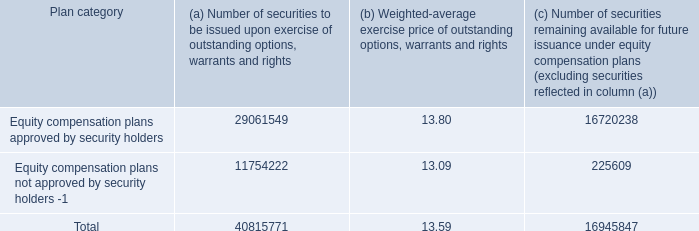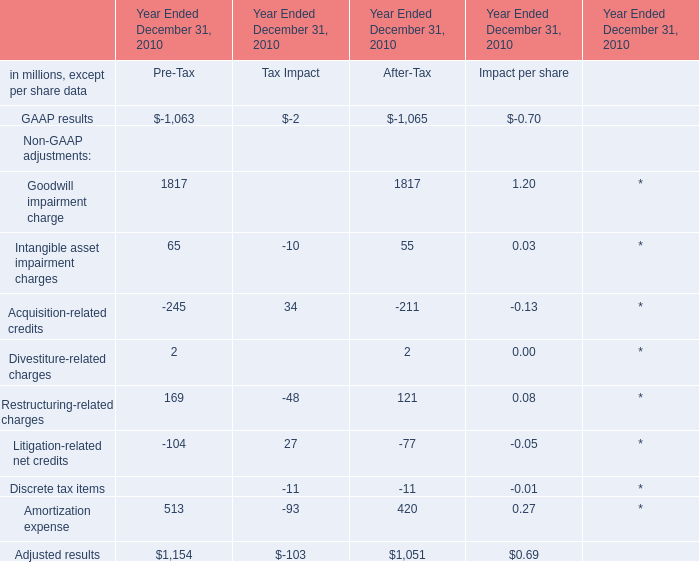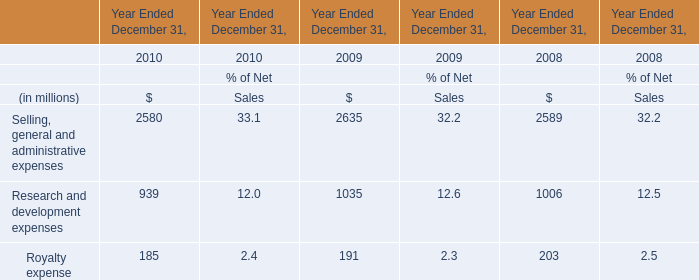What is the average value of Adjusted results of After-Tax in Table 1 and Royalty expense of $ in 2010? (in million) 
Computations: ((1051 + 185) / 2)
Answer: 618.0. 